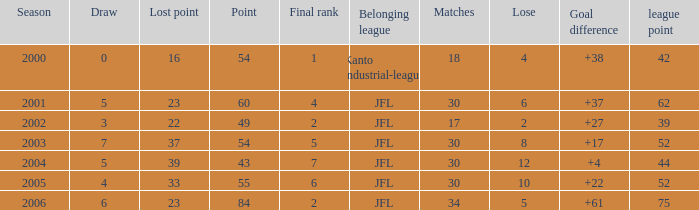I want the total number of matches for draw less than 7 and lost point of 16 with lose more than 4 0.0. 